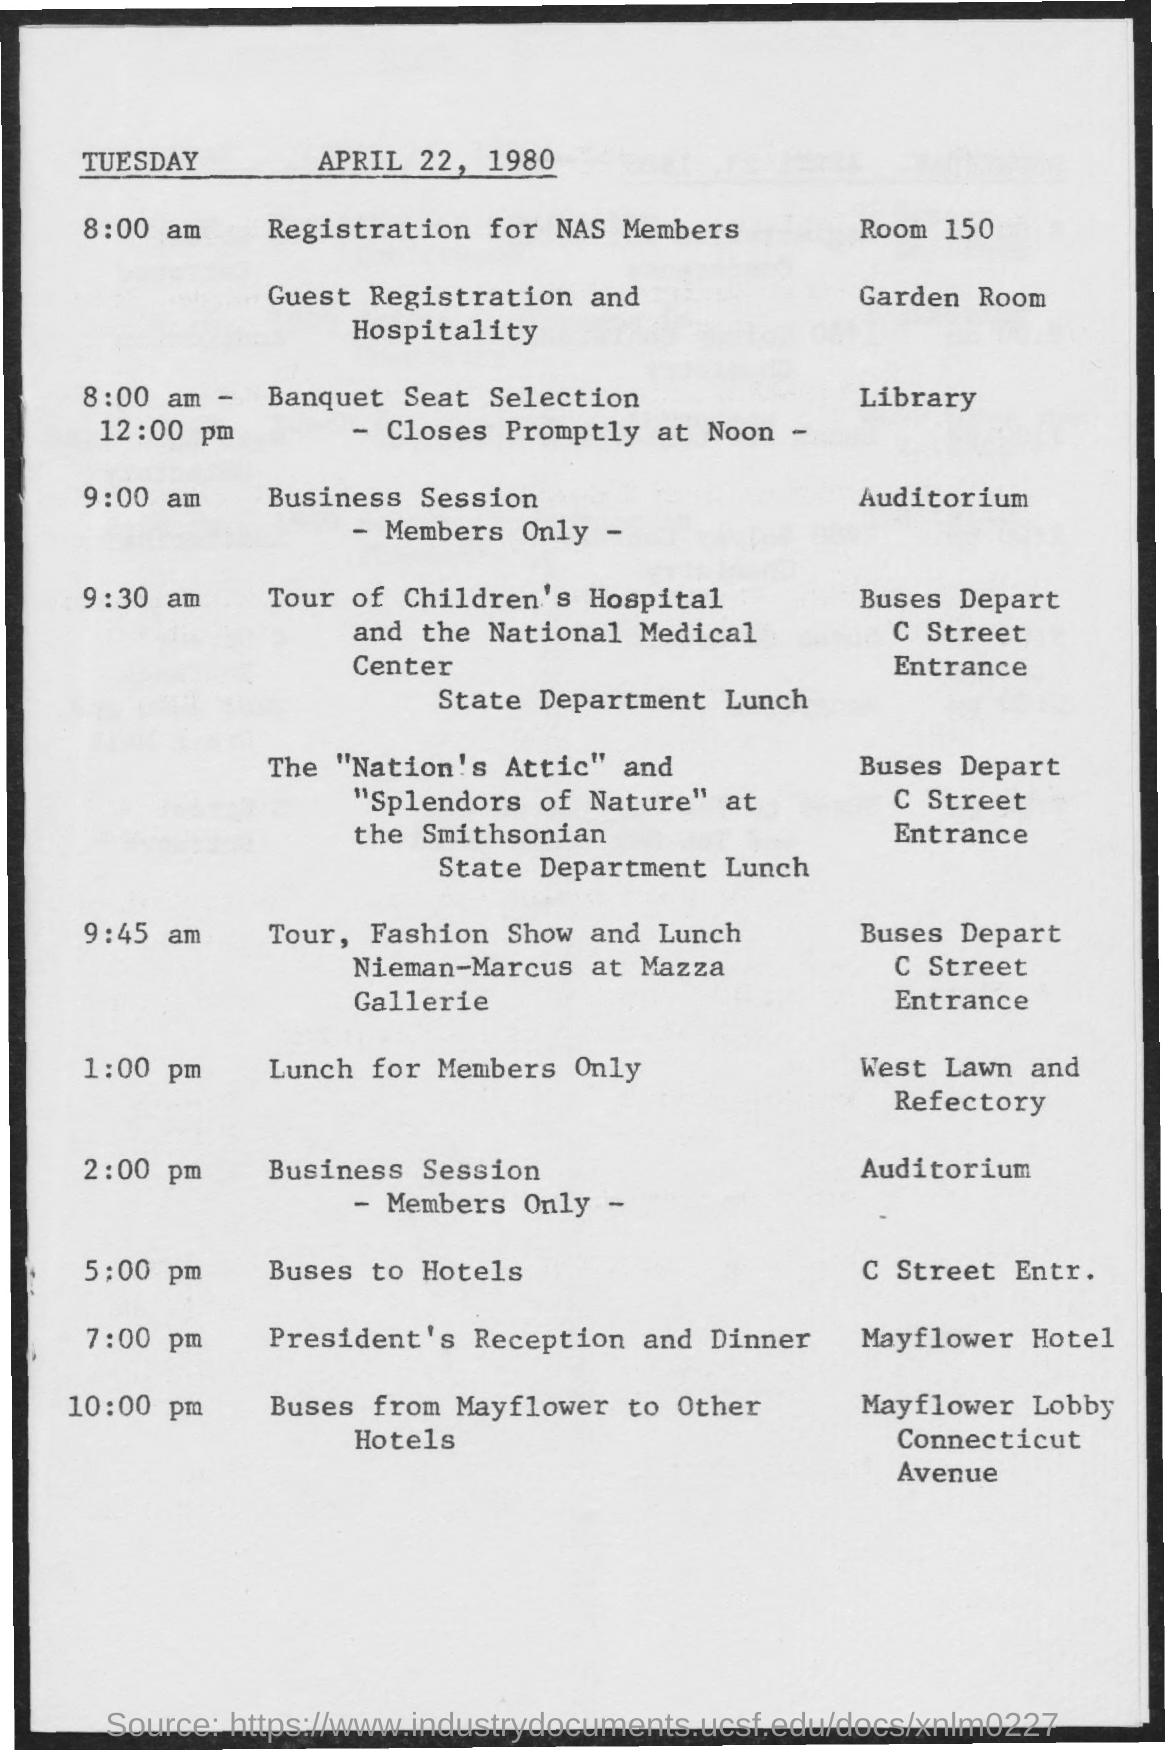Give some essential details in this illustration. The room designated for guest registration and hospitality is the Garden Room. The Mayflower Hotel arranged a hotel reception and dinner for the group. The room set for registration for NAS members is Room 150. 